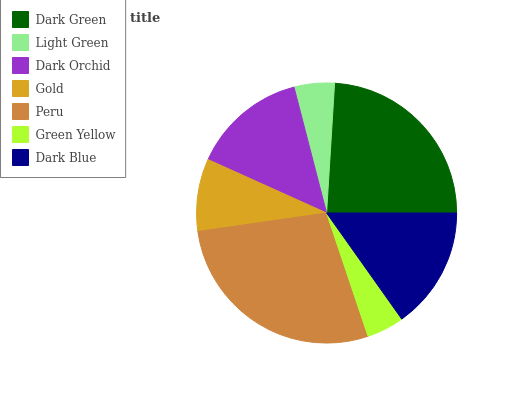Is Green Yellow the minimum?
Answer yes or no. Yes. Is Peru the maximum?
Answer yes or no. Yes. Is Light Green the minimum?
Answer yes or no. No. Is Light Green the maximum?
Answer yes or no. No. Is Dark Green greater than Light Green?
Answer yes or no. Yes. Is Light Green less than Dark Green?
Answer yes or no. Yes. Is Light Green greater than Dark Green?
Answer yes or no. No. Is Dark Green less than Light Green?
Answer yes or no. No. Is Dark Orchid the high median?
Answer yes or no. Yes. Is Dark Orchid the low median?
Answer yes or no. Yes. Is Green Yellow the high median?
Answer yes or no. No. Is Dark Green the low median?
Answer yes or no. No. 